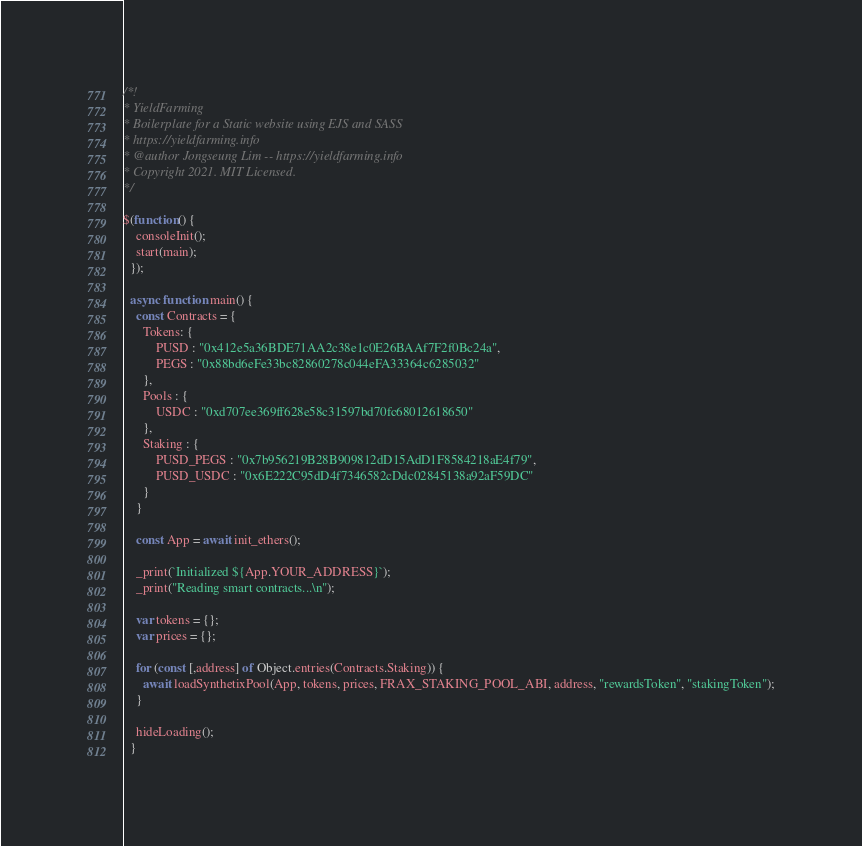Convert code to text. <code><loc_0><loc_0><loc_500><loc_500><_JavaScript_>/*!
* YieldFarming
* Boilerplate for a Static website using EJS and SASS
* https://yieldfarming.info
* @author Jongseung Lim -- https://yieldfarming.info
* Copyright 2021. MIT Licensed.
*/

$(function() {
    consoleInit();
    start(main);
  });

  async function main() {
    const Contracts = {
      Tokens: {
          PUSD : "0x412e5a36BDE71AA2c38e1c0E26BAAf7F2f0Bc24a",
          PEGS : "0x88bd6eFe33bc82860278c044eFA33364c6285032"
      },
      Pools : {
          USDC : "0xd707ee369ff628e58c31597bd70fc68012618650"
      },
      Staking : {
          PUSD_PEGS : "0x7b956219B28B909812dD15AdD1F8584218aE4f79",
          PUSD_USDC : "0x6E222C95dD4f7346582cDdc02845138a92aF59DC"
      }
    }
  
    const App = await init_ethers();
  
    _print(`Initialized ${App.YOUR_ADDRESS}`);
    _print("Reading smart contracts...\n");
  
    var tokens = {};
    var prices = {};
  
    for (const [,address] of Object.entries(Contracts.Staking)) {
      await loadSynthetixPool(App, tokens, prices, FRAX_STAKING_POOL_ABI, address, "rewardsToken", "stakingToken");
    }
  
    hideLoading();
  }</code> 